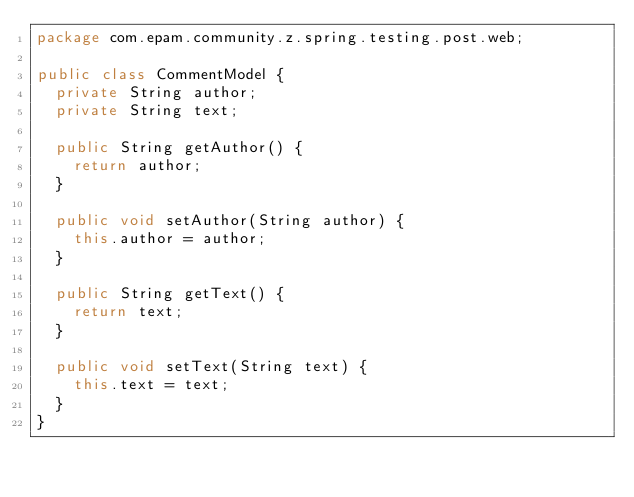Convert code to text. <code><loc_0><loc_0><loc_500><loc_500><_Java_>package com.epam.community.z.spring.testing.post.web;

public class CommentModel {
  private String author;
  private String text;

  public String getAuthor() {
    return author;
  }

  public void setAuthor(String author) {
    this.author = author;
  }

  public String getText() {
    return text;
  }

  public void setText(String text) {
    this.text = text;
  }
}
</code> 